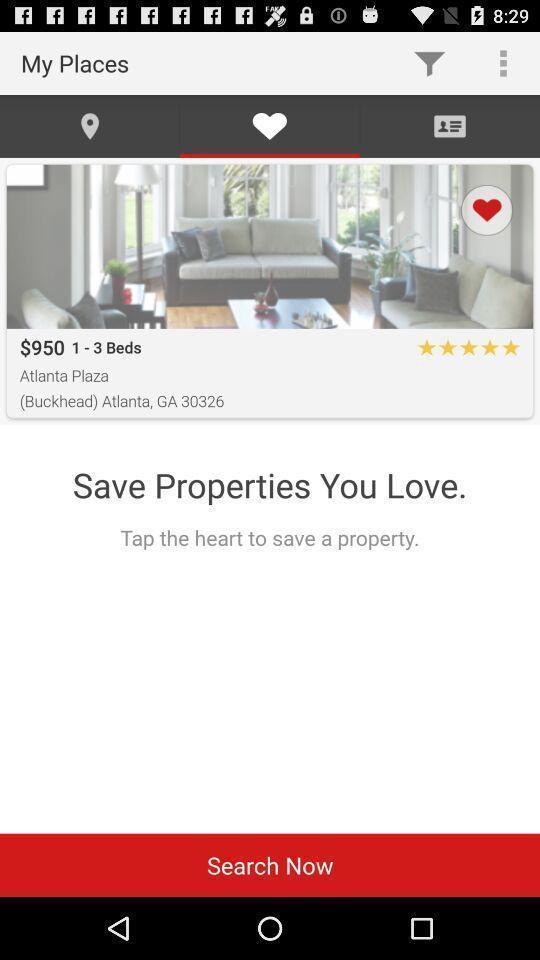Explain the elements present in this screenshot. Screen shows different options. 